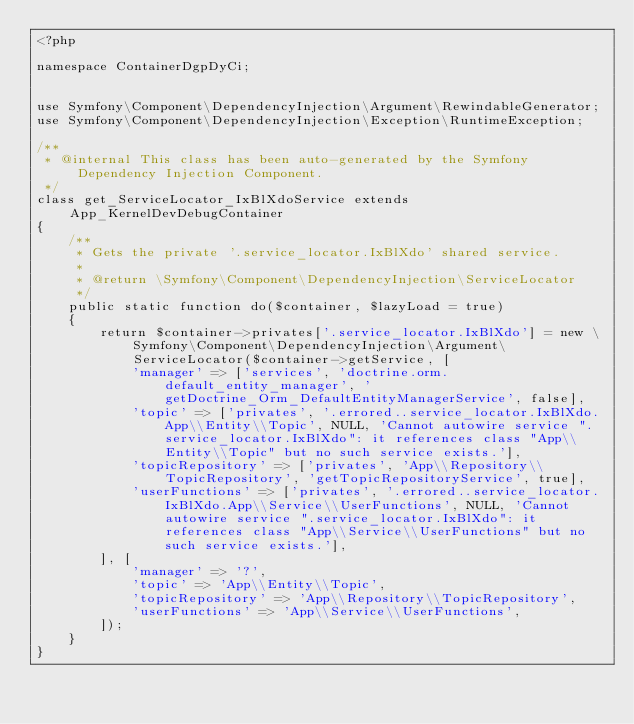<code> <loc_0><loc_0><loc_500><loc_500><_PHP_><?php

namespace ContainerDgpDyCi;


use Symfony\Component\DependencyInjection\Argument\RewindableGenerator;
use Symfony\Component\DependencyInjection\Exception\RuntimeException;

/**
 * @internal This class has been auto-generated by the Symfony Dependency Injection Component.
 */
class get_ServiceLocator_IxBlXdoService extends App_KernelDevDebugContainer
{
    /**
     * Gets the private '.service_locator.IxBlXdo' shared service.
     *
     * @return \Symfony\Component\DependencyInjection\ServiceLocator
     */
    public static function do($container, $lazyLoad = true)
    {
        return $container->privates['.service_locator.IxBlXdo'] = new \Symfony\Component\DependencyInjection\Argument\ServiceLocator($container->getService, [
            'manager' => ['services', 'doctrine.orm.default_entity_manager', 'getDoctrine_Orm_DefaultEntityManagerService', false],
            'topic' => ['privates', '.errored..service_locator.IxBlXdo.App\\Entity\\Topic', NULL, 'Cannot autowire service ".service_locator.IxBlXdo": it references class "App\\Entity\\Topic" but no such service exists.'],
            'topicRepository' => ['privates', 'App\\Repository\\TopicRepository', 'getTopicRepositoryService', true],
            'userFunctions' => ['privates', '.errored..service_locator.IxBlXdo.App\\Service\\UserFunctions', NULL, 'Cannot autowire service ".service_locator.IxBlXdo": it references class "App\\Service\\UserFunctions" but no such service exists.'],
        ], [
            'manager' => '?',
            'topic' => 'App\\Entity\\Topic',
            'topicRepository' => 'App\\Repository\\TopicRepository',
            'userFunctions' => 'App\\Service\\UserFunctions',
        ]);
    }
}
</code> 